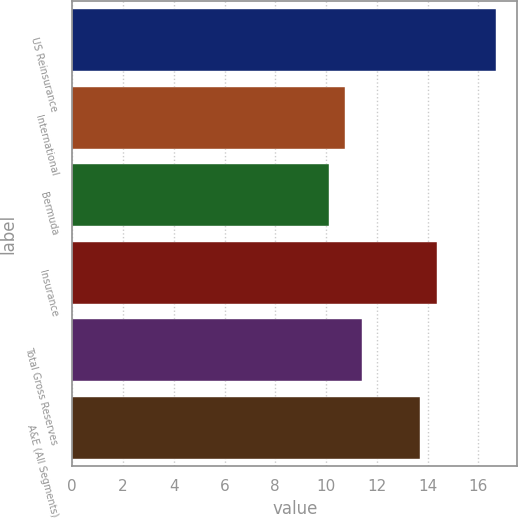<chart> <loc_0><loc_0><loc_500><loc_500><bar_chart><fcel>US Reinsurance<fcel>International<fcel>Bermuda<fcel>Insurance<fcel>Total Gross Reserves<fcel>A&E (All Segments)<nl><fcel>16.7<fcel>10.76<fcel>10.1<fcel>14.36<fcel>11.42<fcel>13.7<nl></chart> 